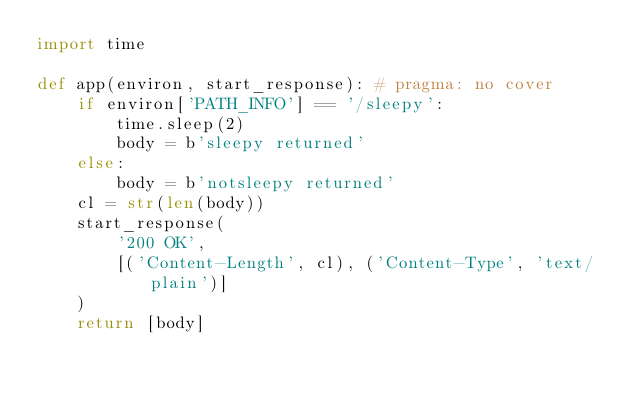Convert code to text. <code><loc_0><loc_0><loc_500><loc_500><_Python_>import time

def app(environ, start_response): # pragma: no cover
    if environ['PATH_INFO'] == '/sleepy':
        time.sleep(2)
        body = b'sleepy returned'
    else:
        body = b'notsleepy returned'
    cl = str(len(body))
    start_response(
        '200 OK',
        [('Content-Length', cl), ('Content-Type', 'text/plain')]
    )
    return [body]
</code> 